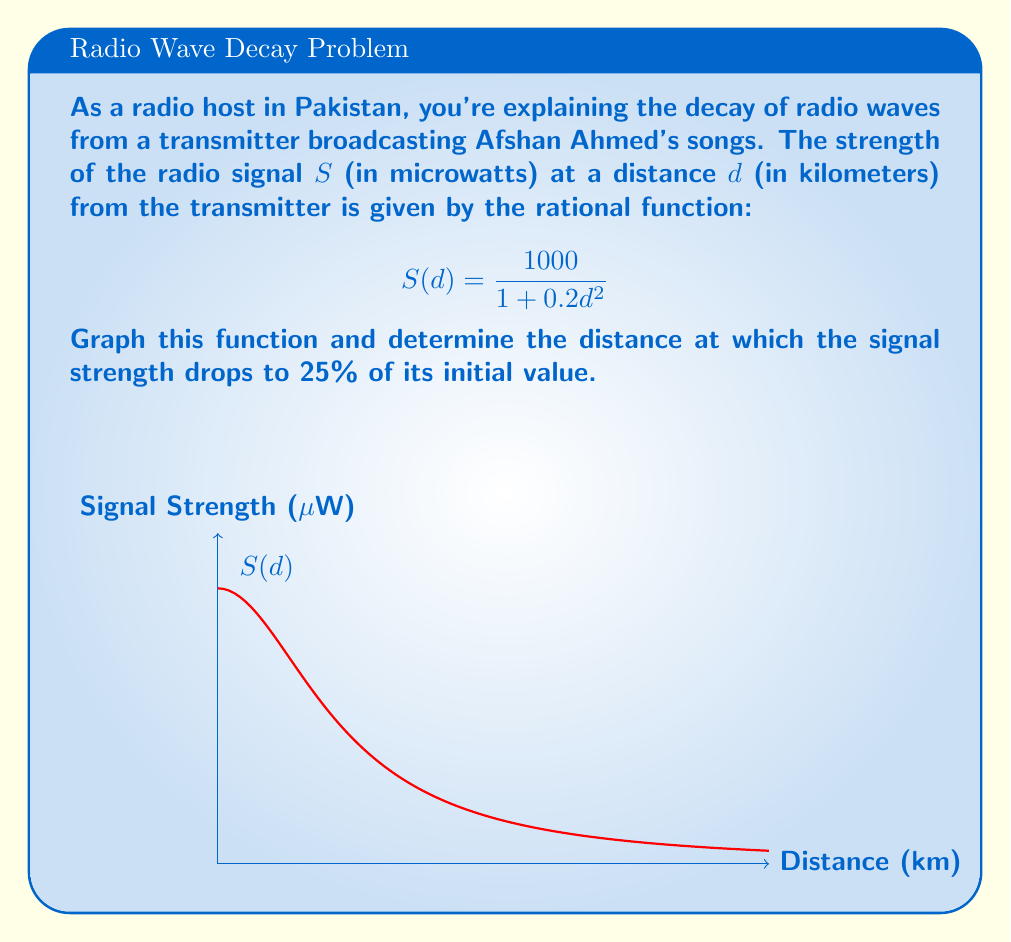Can you answer this question? Let's approach this step-by-step:

1) First, we need to find the initial signal strength. This is when $d = 0$:
   $$S(0) = \frac{1000}{1 + 0.2(0)^2} = \frac{1000}{1} = 1000 \text{ μW}$$

2) We want to find the distance where the signal drops to 25% of this initial value:
   $$0.25 \times 1000 = 250 \text{ μW}$$

3) Now, we set up the equation:
   $$\frac{1000}{1 + 0.2d^2} = 250$$

4) Multiply both sides by $(1 + 0.2d^2)$:
   $$1000 = 250(1 + 0.2d^2)$$

5) Expand the right side:
   $$1000 = 250 + 50d^2$$

6) Subtract 250 from both sides:
   $$750 = 50d^2$$

7) Divide both sides by 50:
   $$15 = d^2$$

8) Take the square root of both sides:
   $$d = \sqrt{15} \approx 3.87 \text{ km}$$

The graph shows a decreasing function that approaches but never reaches zero, which is characteristic of this type of rational function representing signal decay.
Answer: $\sqrt{15} \approx 3.87 \text{ km}$ 